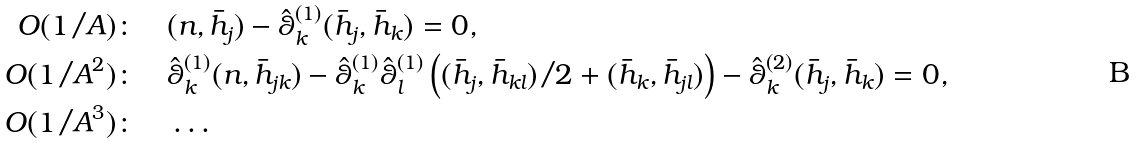<formula> <loc_0><loc_0><loc_500><loc_500>O ( 1 / A ) \colon \quad & ( n , \bar { h } _ { j } ) - \hat { \theta } _ { k } ^ { ( 1 ) } ( \bar { h } _ { j } , \bar { h } _ { k } ) = 0 , \\ O ( 1 / A ^ { 2 } ) \colon \quad & \hat { \theta } _ { k } ^ { ( 1 ) } ( n , \bar { h } _ { j k } ) - \hat { \theta } _ { k } ^ { ( 1 ) } \hat { \theta } _ { l } ^ { ( 1 ) } \left ( ( \bar { h } _ { j } , \bar { h } _ { k l } ) / 2 + ( \bar { h } _ { k } , \bar { h } _ { j l } ) \right ) - \hat { \theta } _ { k } ^ { ( 2 ) } ( \bar { h } _ { j } , \bar { h } _ { k } ) = 0 , \\ O ( 1 / A ^ { 3 } ) \colon \quad & \dots</formula> 